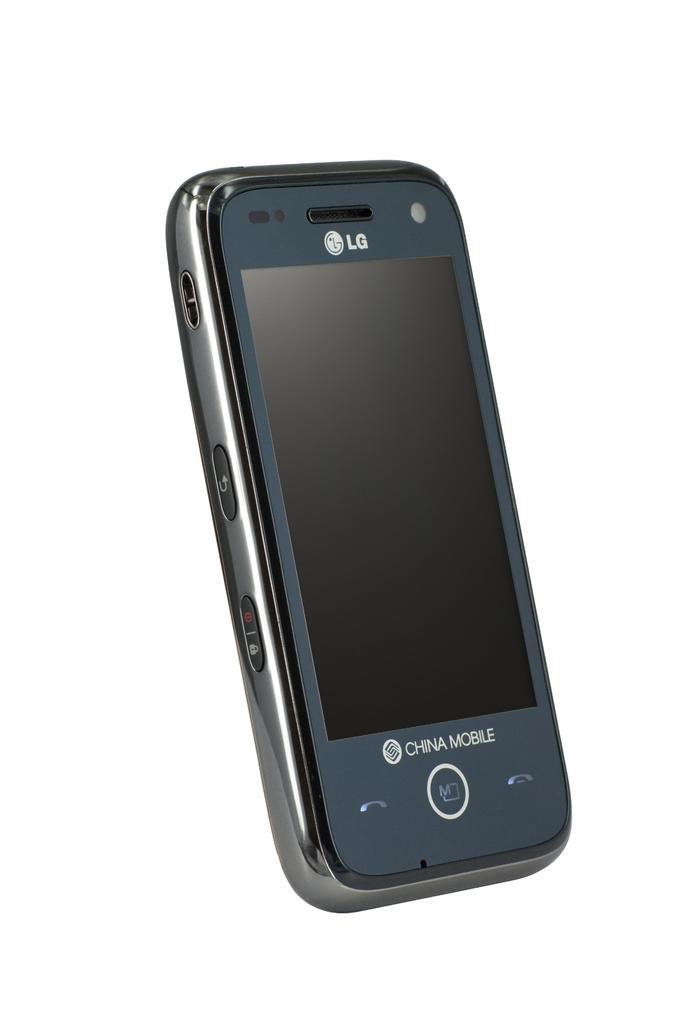<image>
Describe the image concisely. china mobile lg phone that has chrome trim around the side 